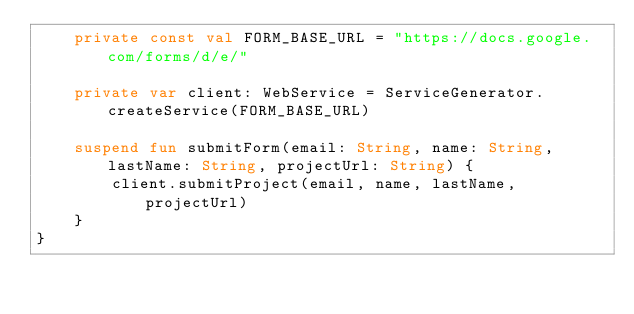<code> <loc_0><loc_0><loc_500><loc_500><_Kotlin_>    private const val FORM_BASE_URL = "https://docs.google.com/forms/d/e/"

    private var client: WebService = ServiceGenerator.createService(FORM_BASE_URL)

    suspend fun submitForm(email: String, name: String, lastName: String, projectUrl: String) {
        client.submitProject(email, name, lastName, projectUrl)
    }
}</code> 